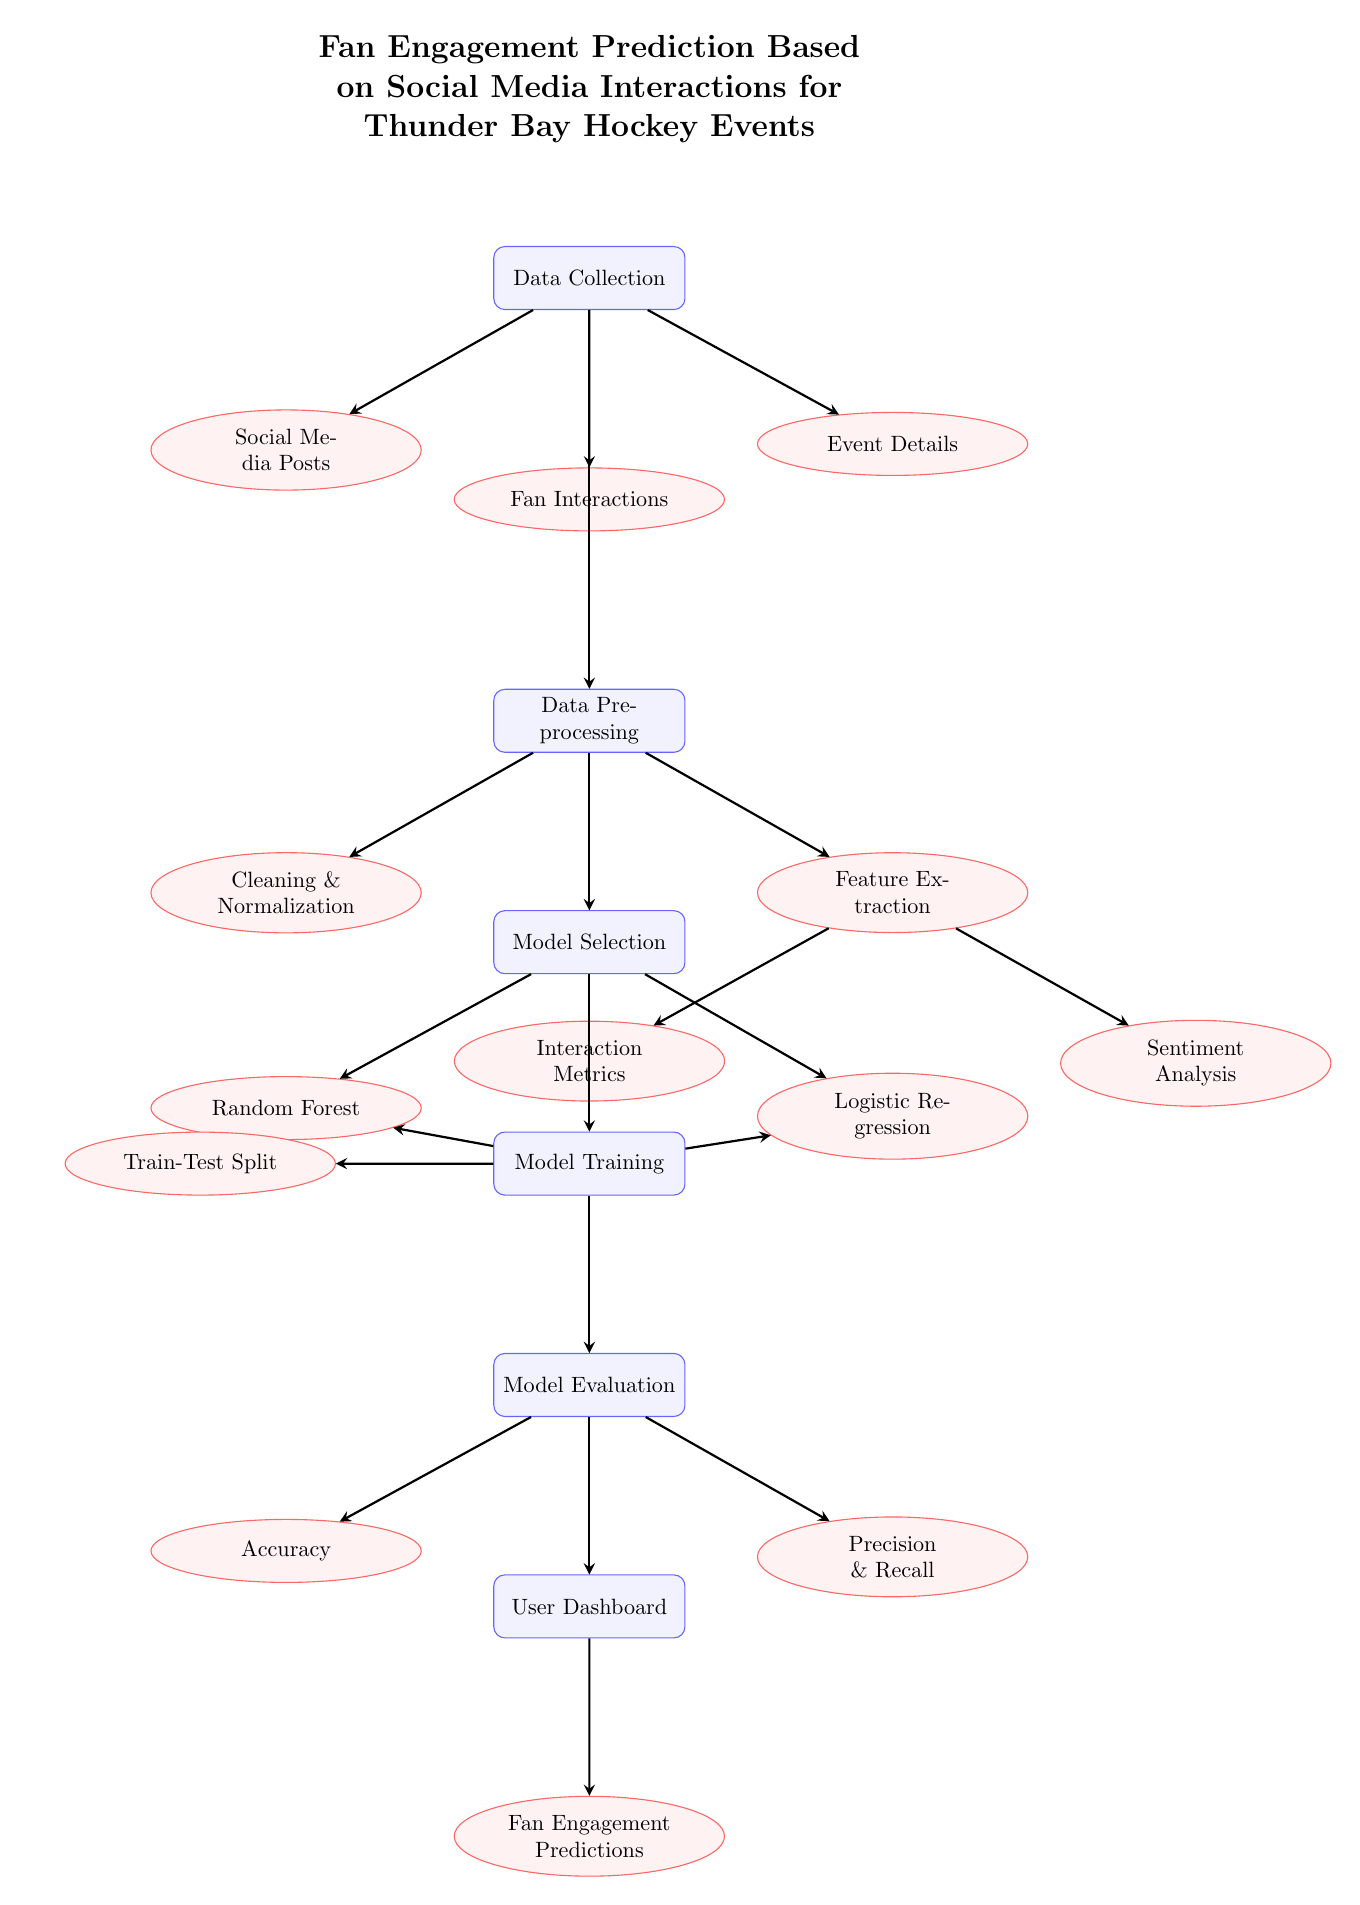What is the first step in the diagram? The first step, as indicated in the diagram, is "Data Collection," which is positioned at the top. It is the starting point for gathering information related to fan engagement.
Answer: Data Collection How many types of models are selected in the Model Selection phase? In the Model Selection phase, there are two types of models listed: "Random Forest" and "Logistic Regression." Therefore, the count is two.
Answer: Two What type of data is included in the Data Collection section? The Data Collection section lists three types of data: "Social Media Posts," "Fan Interactions," and "Event Details." These types are presented in a branching structure below the Data Collection node.
Answer: Social Media Posts, Fan Interactions, Event Details What follows after the Data Preprocessing step? After the Data Preprocessing step, the next process is Model Selection, which takes the cleaned and normalized data as input for determining the appropriate models for training.
Answer: Model Selection What analysis is performed in the Feature Extraction phase? The Feature Extraction phase includes two types of analyses: "Interaction Metrics" and "Sentiment Analysis." These analyses extract important features from the preprocessed data.
Answer: Interaction Metrics, Sentiment Analysis How is the final output presented to the user? The final output is presented through the "User Dashboard," which displays the "Fan Engagement Predictions," indicating the results of the predictive modeling process for fan engagement.
Answer: User Dashboard Which evaluation metrics are used in the Model Evaluation phase? The Model Evaluation phase assesses the performance of the models using two main metrics: "Accuracy" and "Precision & Recall," which provide insights into the effectiveness of the predictions.
Answer: Accuracy, Precision & Recall 